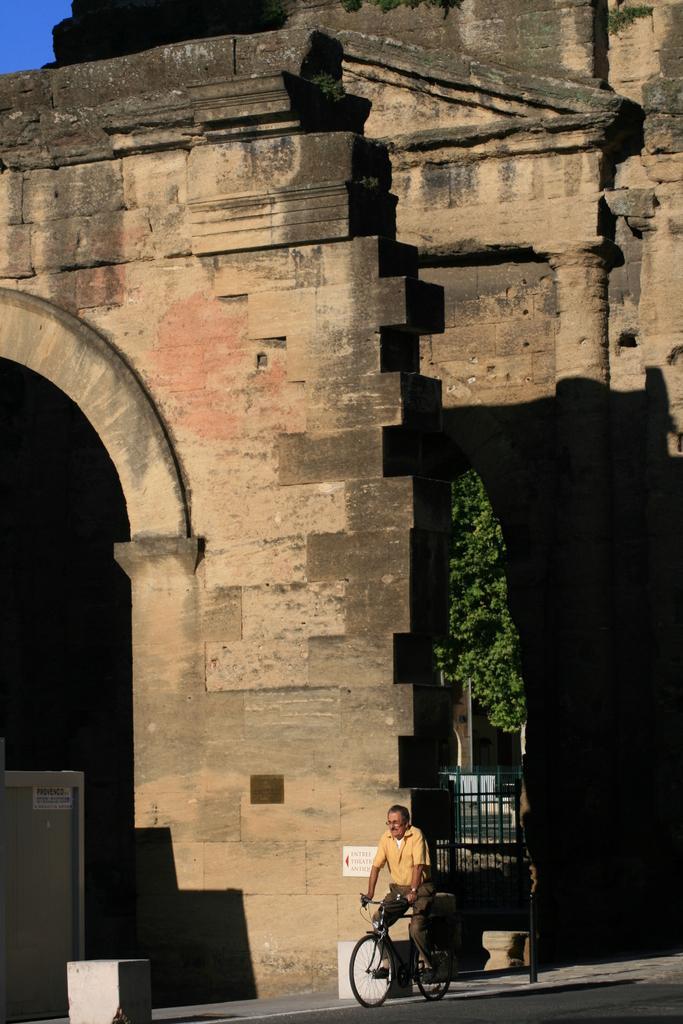Please provide a concise description of this image. In this image we can see a stone arch or building. There is a man riding a bicycle. In the background of the image we can see a tree and a gate. 